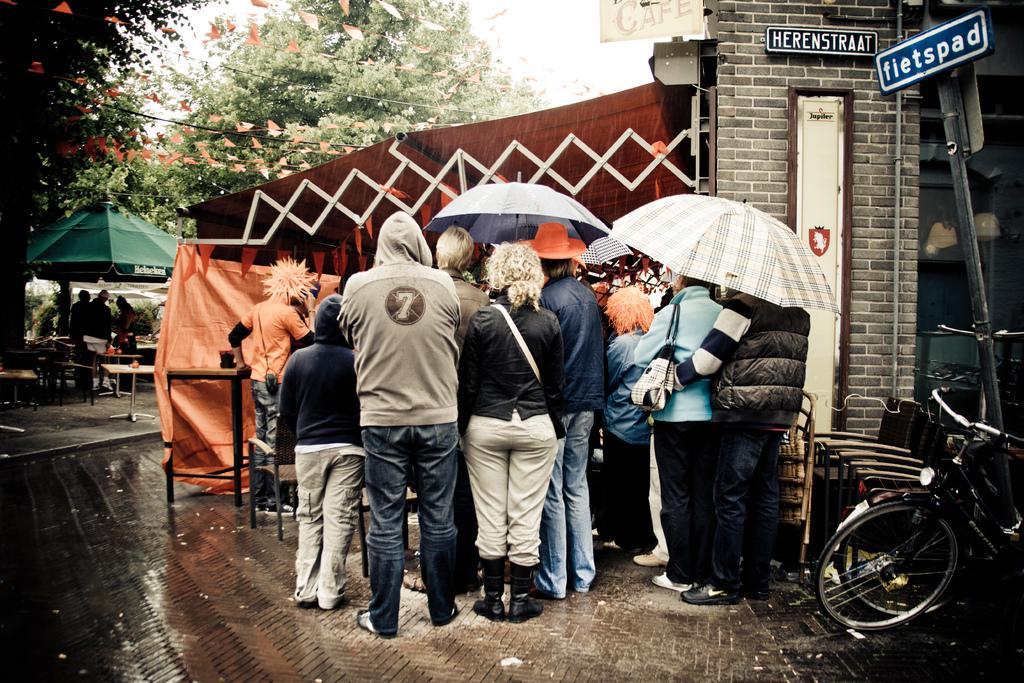Can you describe this image briefly? In this picture we can see people and a bicycle on the ground, here we can see tents, umbrellas, name boards, wall and some objects and in the background we can see trees, sky. 